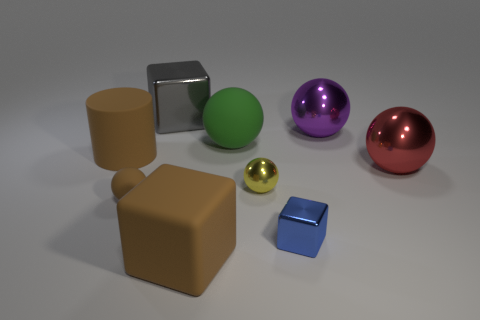There is a large red thing that is the same shape as the tiny yellow thing; what is its material?
Offer a very short reply. Metal. The big cube that is behind the tiny ball in front of the yellow ball is what color?
Your response must be concise. Gray. How big is the metallic cube in front of the brown rubber thing that is behind the yellow ball?
Keep it short and to the point. Small. What size is the cylinder that is the same color as the tiny matte thing?
Ensure brevity in your answer.  Large. How many other things are the same size as the brown cube?
Give a very brief answer. 5. What color is the metal block that is right of the tiny sphere right of the large matte object in front of the small blue metal cube?
Ensure brevity in your answer.  Blue. What number of other things are the same shape as the big red thing?
Provide a succinct answer. 4. The big brown object that is on the right side of the big metal block has what shape?
Give a very brief answer. Cube. Is there a rubber thing that is left of the big matte thing that is in front of the red thing?
Make the answer very short. Yes. What is the color of the rubber object that is both left of the large green sphere and on the right side of the brown sphere?
Ensure brevity in your answer.  Brown. 